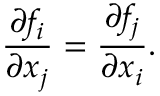Convert formula to latex. <formula><loc_0><loc_0><loc_500><loc_500>\frac { \partial { f } _ { i } } { \partial x _ { j } } = \frac { \partial { f } _ { j } } { \partial x _ { i } } .</formula> 